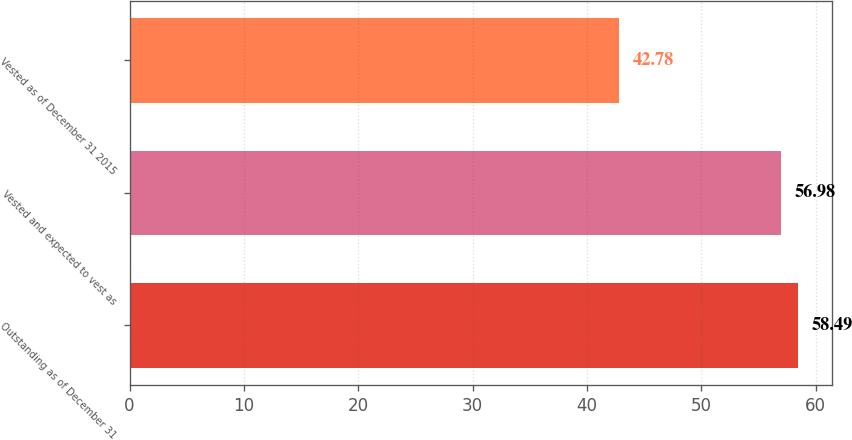Convert chart. <chart><loc_0><loc_0><loc_500><loc_500><bar_chart><fcel>Outstanding as of December 31<fcel>Vested and expected to vest as<fcel>Vested as of December 31 2015<nl><fcel>58.49<fcel>56.98<fcel>42.78<nl></chart> 